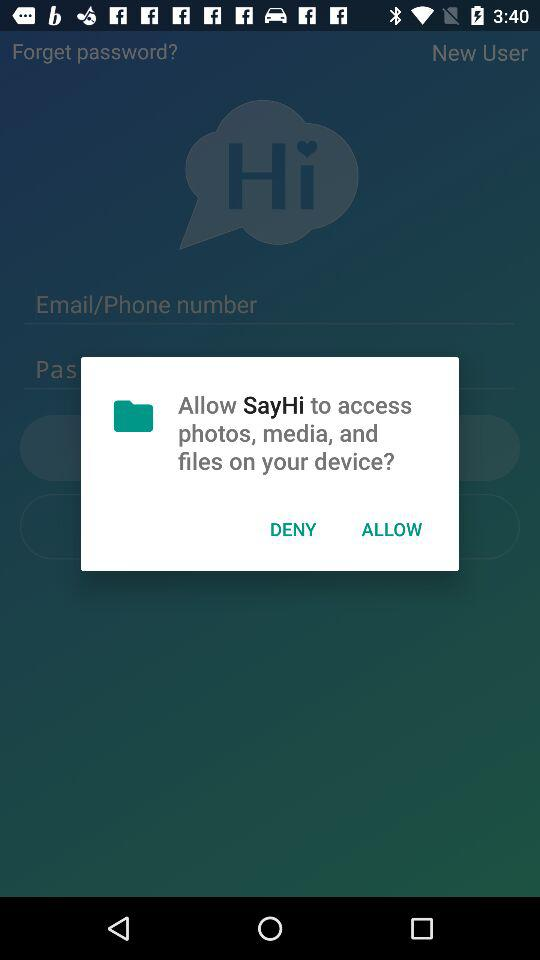What application has asked for permission? The application that has asked for permission is "SayHi". 